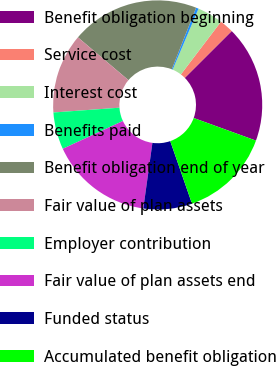<chart> <loc_0><loc_0><loc_500><loc_500><pie_chart><fcel>Benefit obligation beginning<fcel>Service cost<fcel>Interest cost<fcel>Benefits paid<fcel>Benefit obligation end of year<fcel>Fair value of plan assets<fcel>Employer contribution<fcel>Fair value of plan assets end<fcel>Funded status<fcel>Accumulated benefit obligation<nl><fcel>18.03%<fcel>2.17%<fcel>3.96%<fcel>0.39%<fcel>19.81%<fcel>12.34%<fcel>5.74%<fcel>15.91%<fcel>7.52%<fcel>14.13%<nl></chart> 